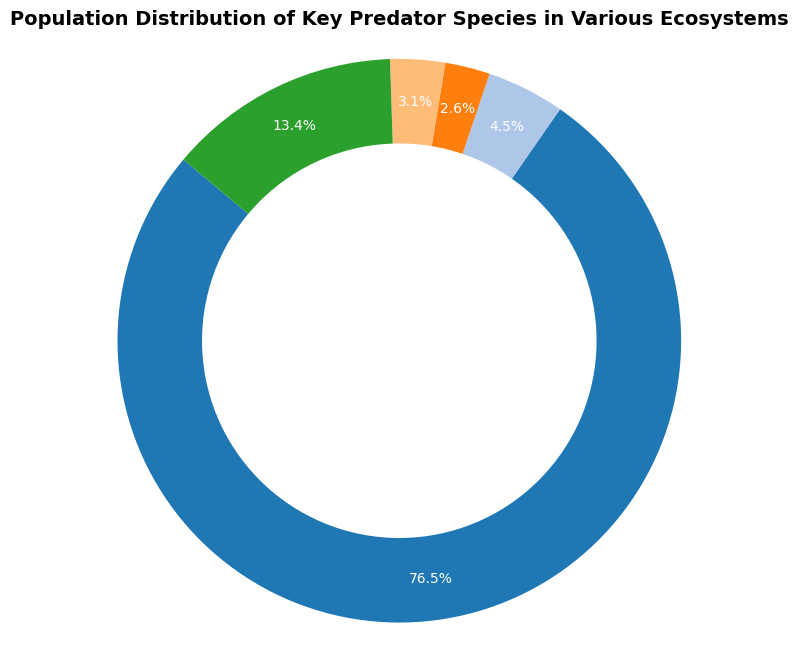What's the predominant ecosystem by predator population in the chart? Upon examining the pie chart, the segment corresponding to the "Forest" ecosystem is the largest section, indicating it has the highest predator population compared to other ecosystems.
Answer: Forest Which ecosystem has the smallest predator population? By looking at the smallest segment of the ring chart, the "Ocean" ecosystem has the smallest population relative to others.
Answer: Ocean Compare the predator populations of the Tundra and Rainforest ecosystems. Which one is higher? By visually comparing the sizes of the sectors, the Tundra's section is larger than the Rainforest's section, indicating a higher predator population.
Answer: Tundra How does the predator population of the Savanna compare to that of the Forest? The Forest segment is noticeably larger than the Savanna segment, indicating that the Forest ecosystem has a greater predator population than the Savanna ecosystem.
Answer: Forest Estimate the percentage of the total predator population that the Rainforest ecosystem represents in the pie chart. By looking at the percentage labels on the wedges, the Rainforest section represents approximately 17% of the total predator population.
Answer: 17% What is the total predator population of the Savanna and Ocean ecosystems combined? The populations of Savanna and Ocean are 39100 and 58500 respectively. Summing these values gives 97600.
Answer: 97600 Compare the sizes of the sections for the Great White Shark and African Lion populations. Which is represented in the larger ecosystem? The African Lion is part of the Savanna ecosystem, which has a larger section compared to the Ocean ecosystem that includes the Great White Shark.
Answer: African Lion Determine the average predator population for the ecosystems shown. First sum the total populations: 3561000. Then divide by the number of ecosystems (5), the average population calculation is 3561000 / 5 = 712200.
Answer: 712200 Examine the visual style of the segment corresponding to the Tundra ecosystem. Describe its relative size and color. The Tundra segment is sizable, second largest in the chart, depicted with a specific color from the color palette used in the pie chart.
Answer: Large, distinct color Combining the predator populations of the Arctic Fox and Polar Bear, how does it compare to the total predator population represented in the Savanna segment? Arctic Fox and Polar Bear populations are 110000 and 26000 respectively, summing to 136000. The total for Savanna is 39100, indicating that the combined population of Arctic Fox and Polar Bear is greater.
Answer: Arctic Fox and Polar Bear 